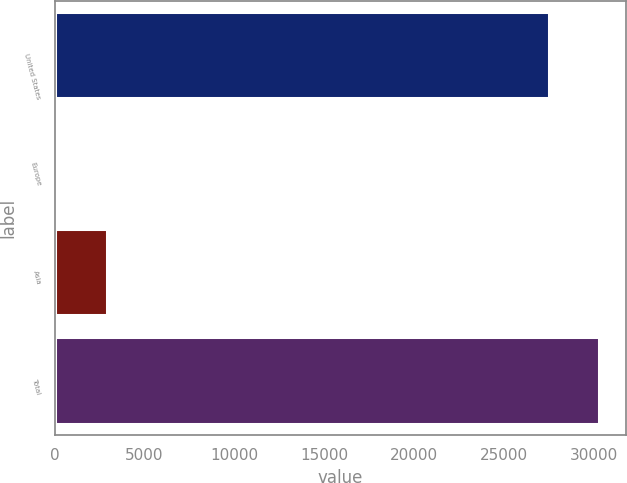Convert chart. <chart><loc_0><loc_0><loc_500><loc_500><bar_chart><fcel>United States<fcel>Europe<fcel>Asia<fcel>Total<nl><fcel>27505<fcel>133<fcel>2906.4<fcel>30278.4<nl></chart> 